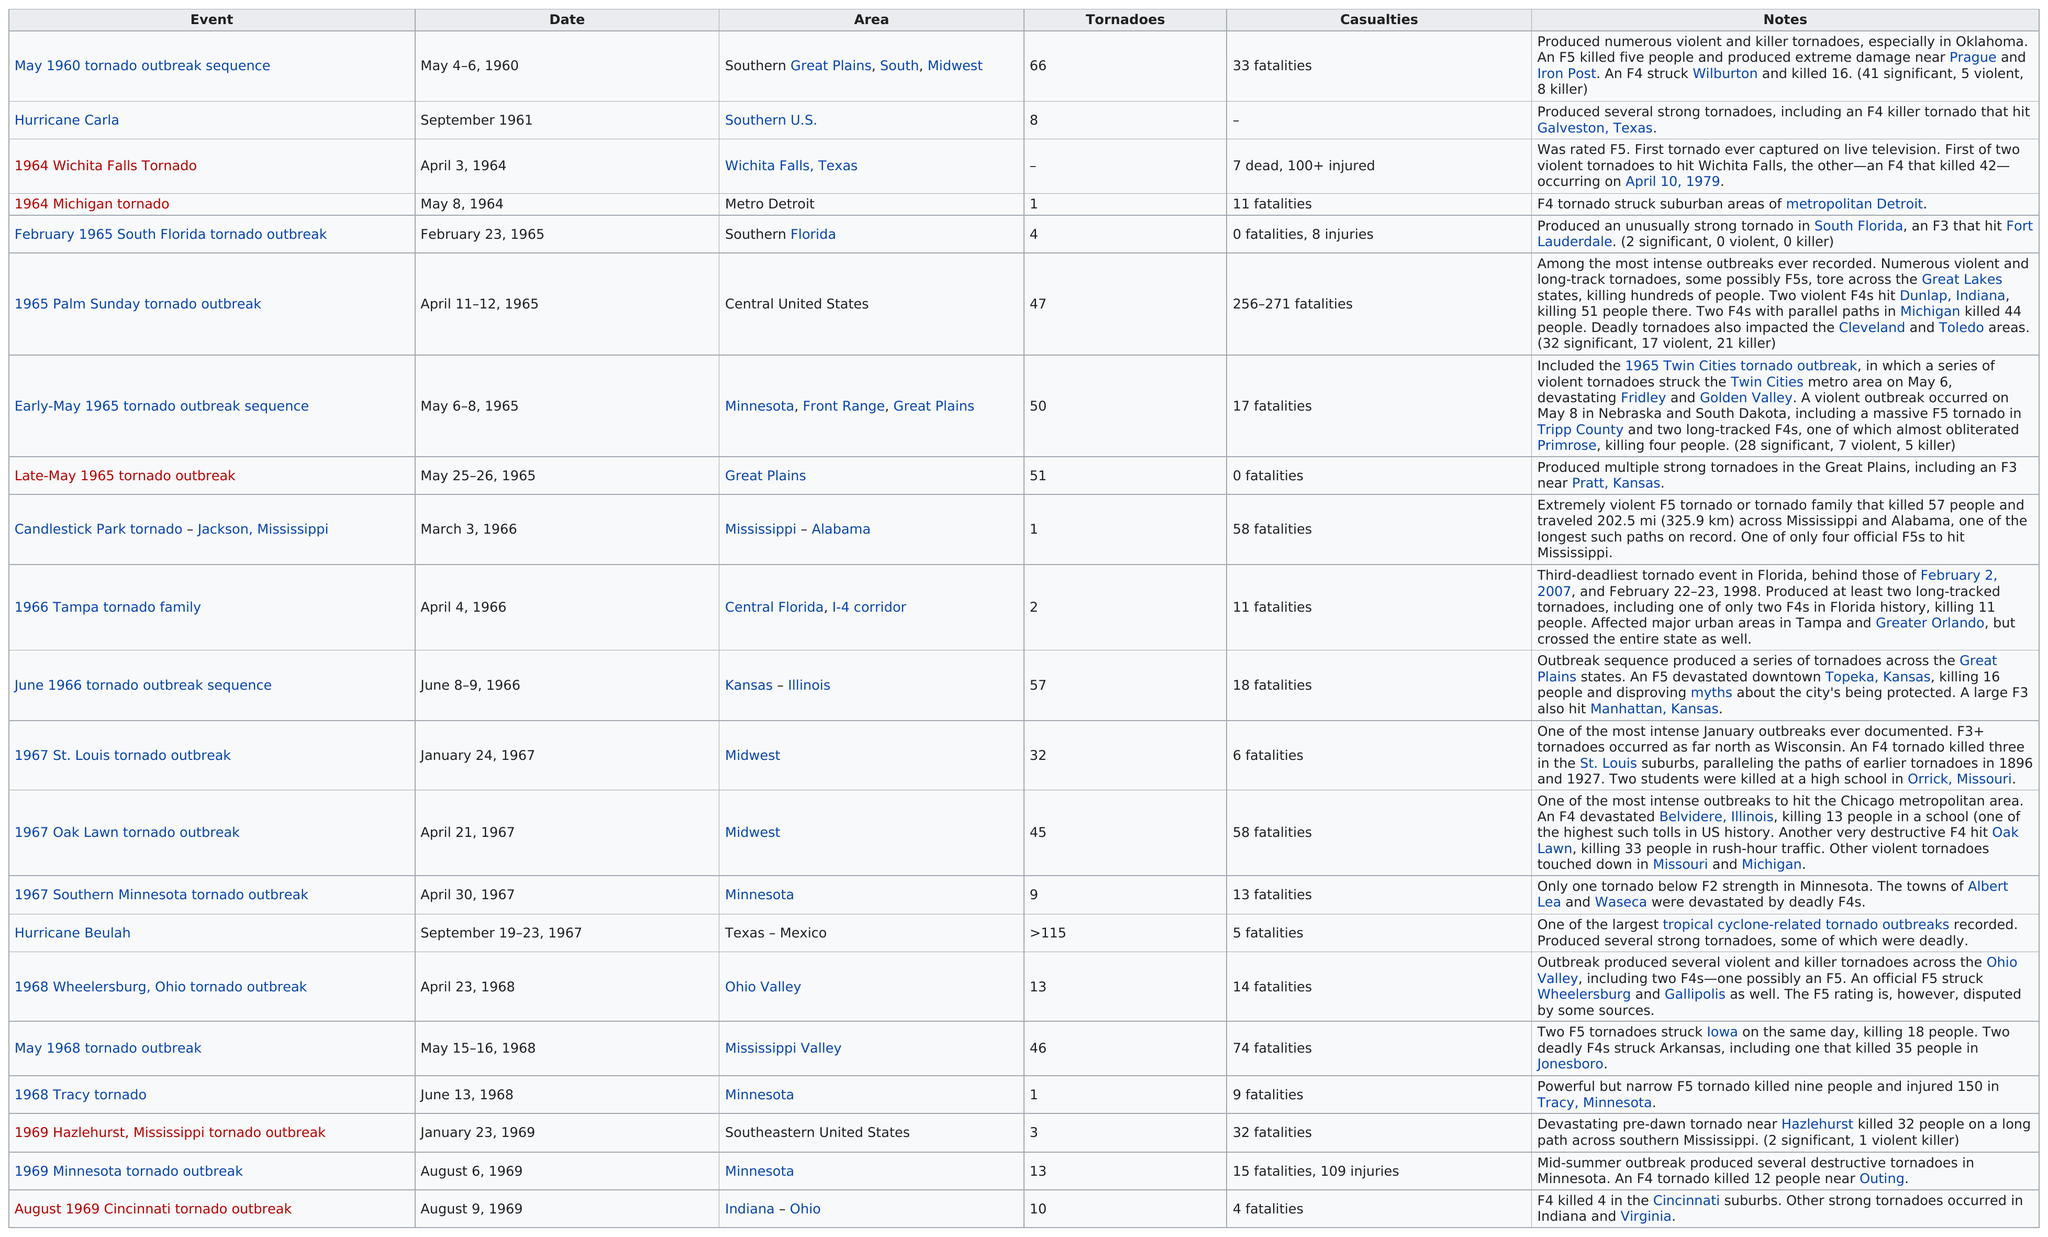Specify some key components in this picture. There were two events that did not result in any casualties. The Candlestick Park tornado, which occurred after the late-May 1965 tornado outbreak, was a tornado that occurred in Jackson, Mississippi. The Candlestick Park tornado, which occurred in 1964, is the one that killed more people than the 1964 Michigan tornado. The late-May 1965 tornado outbreak was notable for having a tornado with no fatalities. The 1965 Palm Sunday tornado outbreak was the event with the highest casualties. 